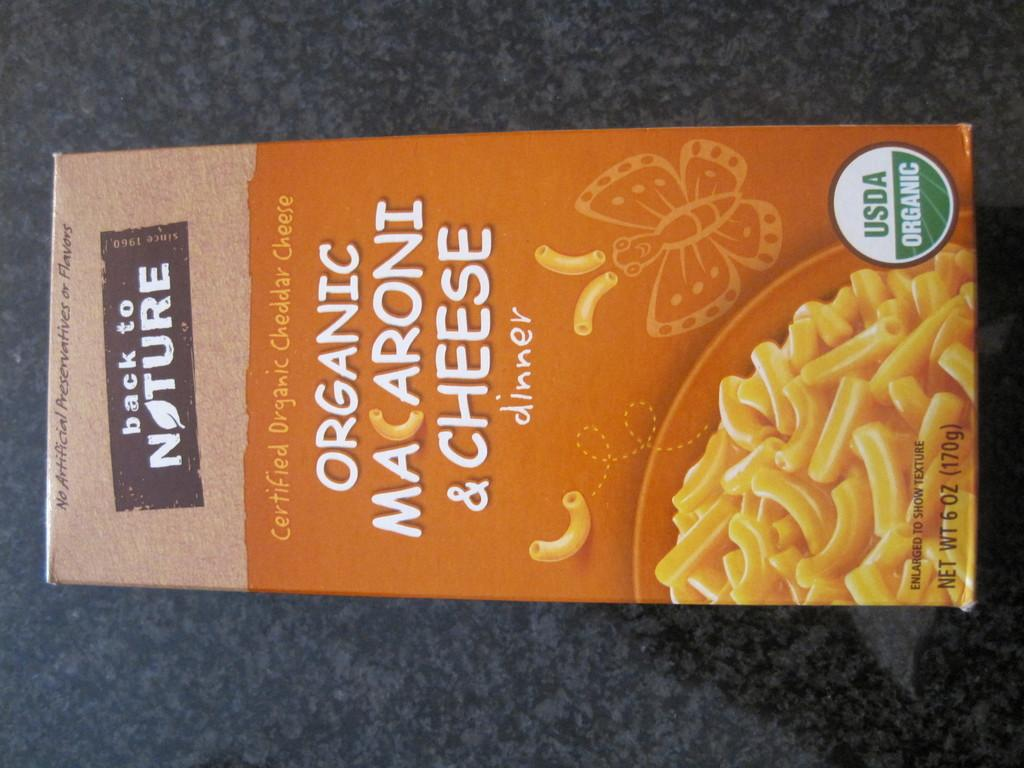<image>
Share a concise interpretation of the image provided. A box of organic macaroni and cheese is lying on a dark surface. 